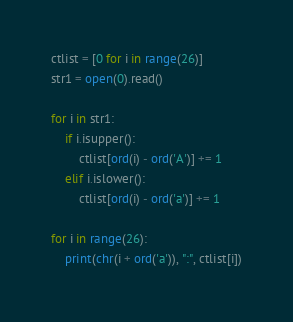Convert code to text. <code><loc_0><loc_0><loc_500><loc_500><_Python_>ctlist = [0 for i in range(26)]
str1 = open(0).read()

for i in str1:
    if i.isupper():
        ctlist[ord(i) - ord('A')] += 1
    elif i.islower():
        ctlist[ord(i) - ord('a')] += 1

for i in range(26):
    print(chr(i + ord('a')), ":", ctlist[i])
</code> 